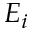Convert formula to latex. <formula><loc_0><loc_0><loc_500><loc_500>E _ { i }</formula> 